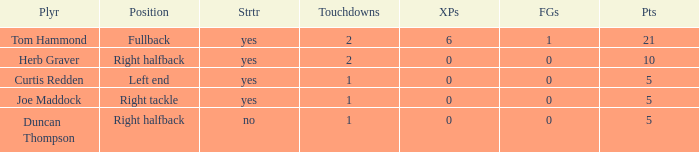Could you help me parse every detail presented in this table? {'header': ['Plyr', 'Position', 'Strtr', 'Touchdowns', 'XPs', 'FGs', 'Pts'], 'rows': [['Tom Hammond', 'Fullback', 'yes', '2', '6', '1', '21'], ['Herb Graver', 'Right halfback', 'yes', '2', '0', '0', '10'], ['Curtis Redden', 'Left end', 'yes', '1', '0', '0', '5'], ['Joe Maddock', 'Right tackle', 'yes', '1', '0', '0', '5'], ['Duncan Thompson', 'Right halfback', 'no', '1', '0', '0', '5']]} Name the most extra points for right tackle 0.0. 